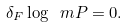Convert formula to latex. <formula><loc_0><loc_0><loc_500><loc_500>\delta _ { F } \log \ m P = 0 .</formula> 